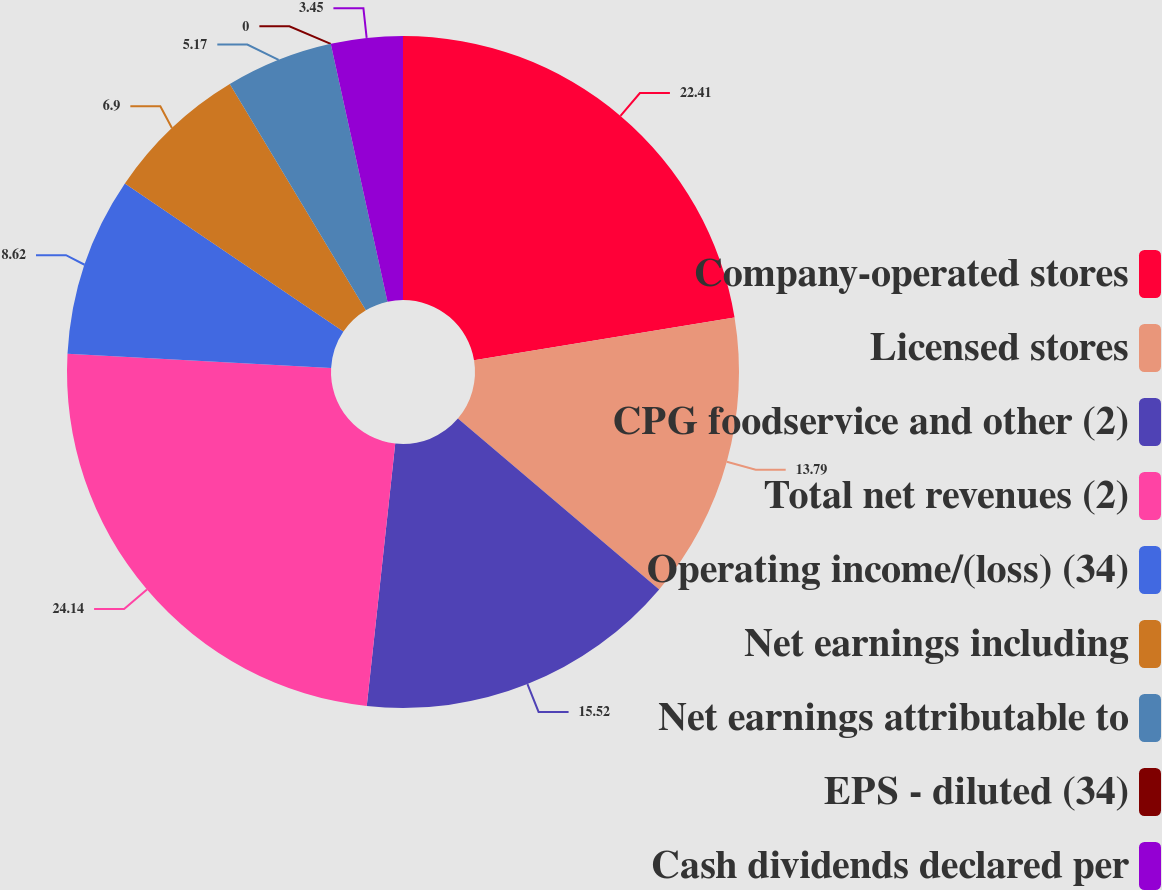Convert chart to OTSL. <chart><loc_0><loc_0><loc_500><loc_500><pie_chart><fcel>Company-operated stores<fcel>Licensed stores<fcel>CPG foodservice and other (2)<fcel>Total net revenues (2)<fcel>Operating income/(loss) (34)<fcel>Net earnings including<fcel>Net earnings attributable to<fcel>EPS - diluted (34)<fcel>Cash dividends declared per<nl><fcel>22.41%<fcel>13.79%<fcel>15.52%<fcel>24.14%<fcel>8.62%<fcel>6.9%<fcel>5.17%<fcel>0.0%<fcel>3.45%<nl></chart> 